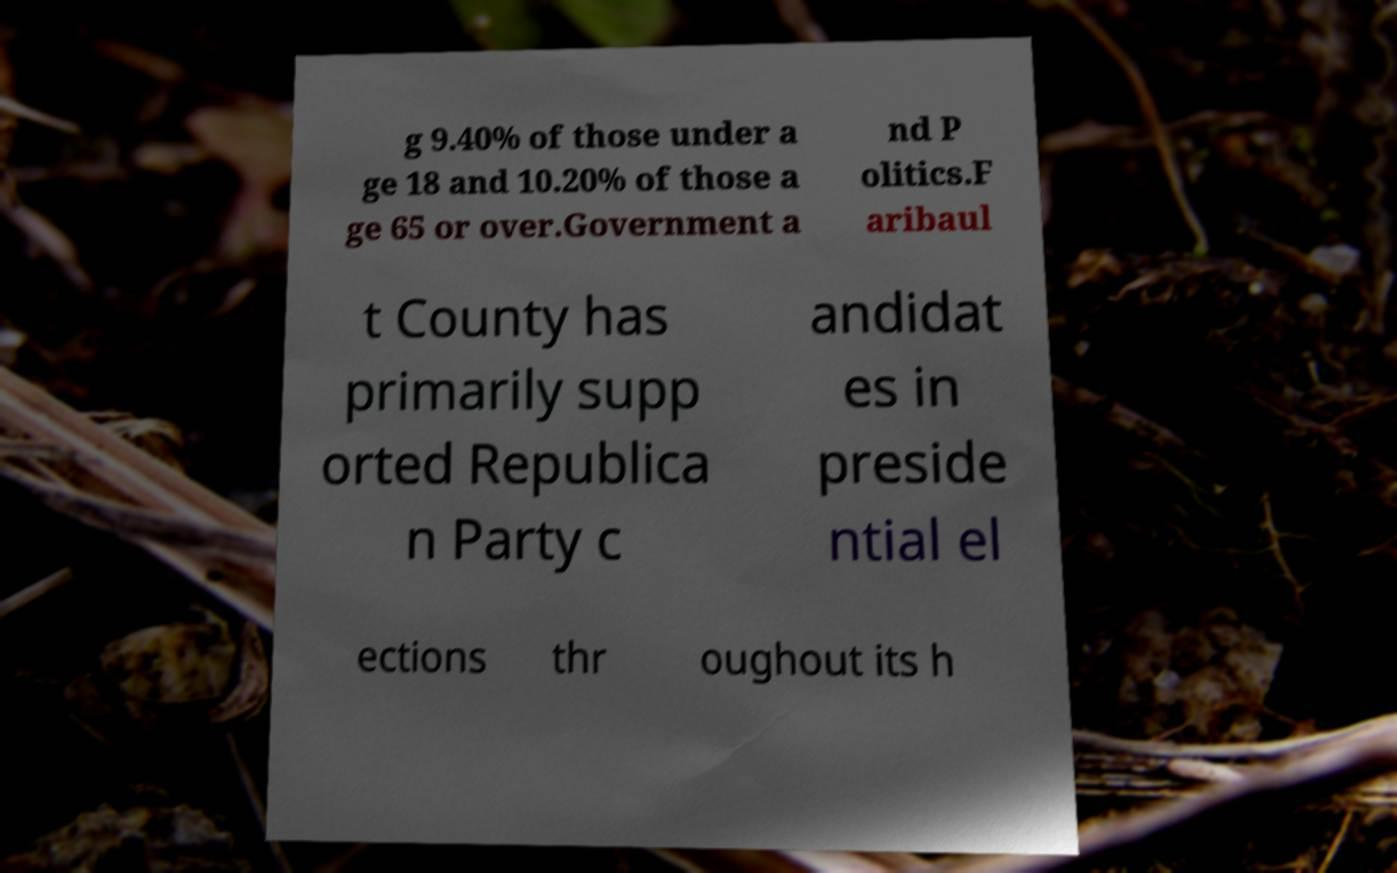For documentation purposes, I need the text within this image transcribed. Could you provide that? g 9.40% of those under a ge 18 and 10.20% of those a ge 65 or over.Government a nd P olitics.F aribaul t County has primarily supp orted Republica n Party c andidat es in preside ntial el ections thr oughout its h 